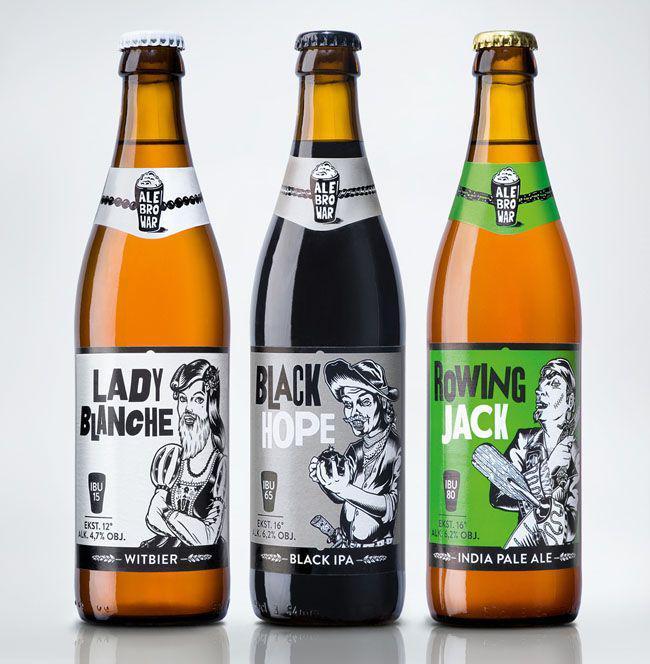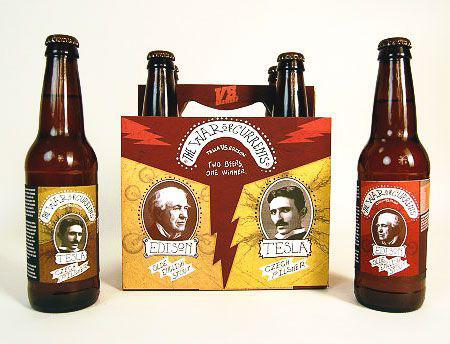The first image is the image on the left, the second image is the image on the right. Given the left and right images, does the statement "At least eight bottles of beer are shown." hold true? Answer yes or no. Yes. The first image is the image on the left, the second image is the image on the right. Considering the images on both sides, is "Each image contains exactly three bottles." valid? Answer yes or no. No. 